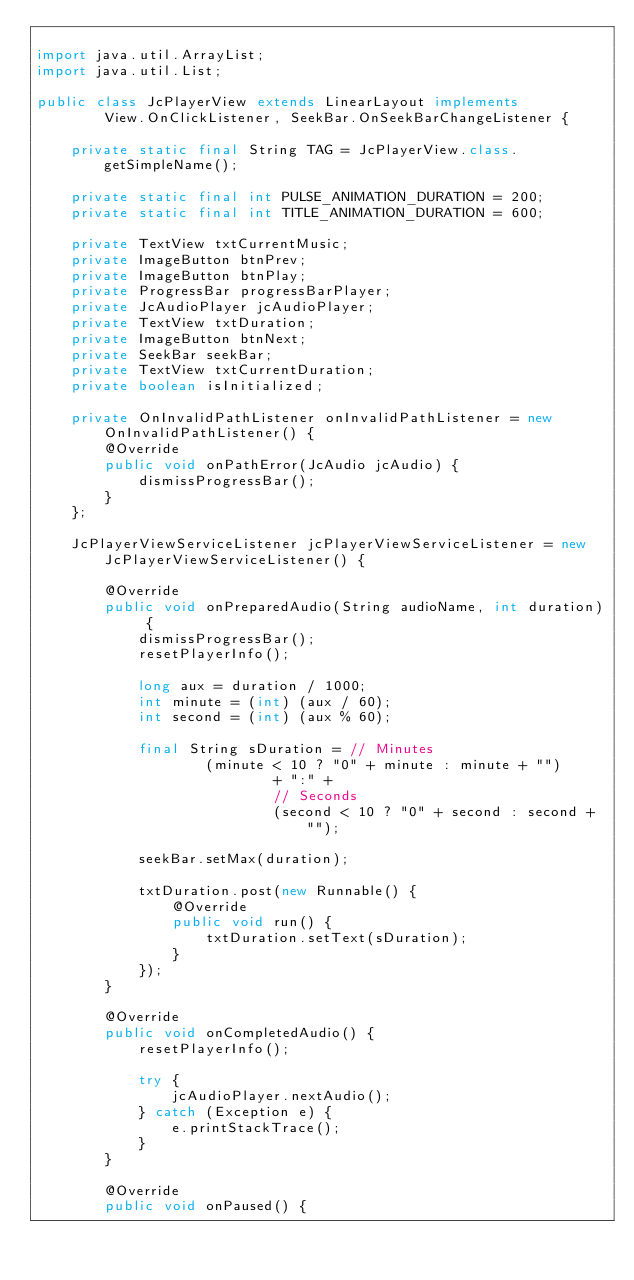<code> <loc_0><loc_0><loc_500><loc_500><_Java_>
import java.util.ArrayList;
import java.util.List;

public class JcPlayerView extends LinearLayout implements
        View.OnClickListener, SeekBar.OnSeekBarChangeListener {

    private static final String TAG = JcPlayerView.class.getSimpleName();

    private static final int PULSE_ANIMATION_DURATION = 200;
    private static final int TITLE_ANIMATION_DURATION = 600;

    private TextView txtCurrentMusic;
    private ImageButton btnPrev;
    private ImageButton btnPlay;
    private ProgressBar progressBarPlayer;
    private JcAudioPlayer jcAudioPlayer;
    private TextView txtDuration;
    private ImageButton btnNext;
    private SeekBar seekBar;
    private TextView txtCurrentDuration;
    private boolean isInitialized;

    private OnInvalidPathListener onInvalidPathListener = new OnInvalidPathListener() {
        @Override
        public void onPathError(JcAudio jcAudio) {
            dismissProgressBar();
        }
    };

    JcPlayerViewServiceListener jcPlayerViewServiceListener = new JcPlayerViewServiceListener() {

        @Override
        public void onPreparedAudio(String audioName, int duration) {
            dismissProgressBar();
            resetPlayerInfo();

            long aux = duration / 1000;
            int minute = (int) (aux / 60);
            int second = (int) (aux % 60);

            final String sDuration = // Minutes
                    (minute < 10 ? "0" + minute : minute + "")
                            + ":" +
                            // Seconds
                            (second < 10 ? "0" + second : second + "");

            seekBar.setMax(duration);

            txtDuration.post(new Runnable() {
                @Override
                public void run() {
                    txtDuration.setText(sDuration);
                }
            });
        }

        @Override
        public void onCompletedAudio() {
            resetPlayerInfo();

            try {
                jcAudioPlayer.nextAudio();
            } catch (Exception e) {
                e.printStackTrace();
            }
        }

        @Override
        public void onPaused() {</code> 